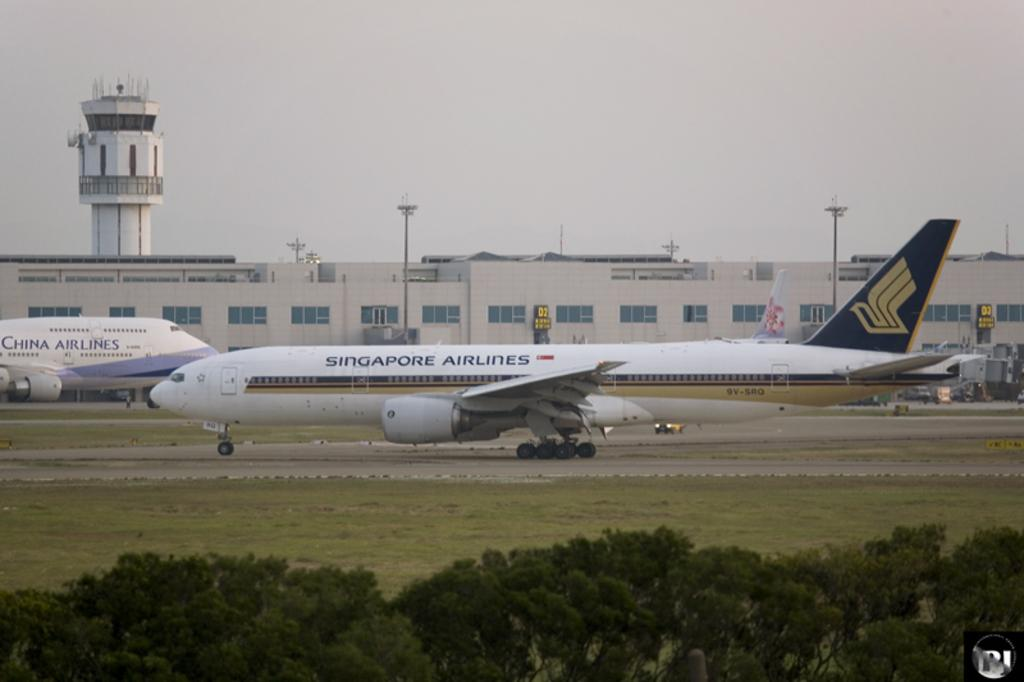Provide a one-sentence caption for the provided image. A plane from China Airlines and a plane from Singapore Airlines heading in opposite directions. 